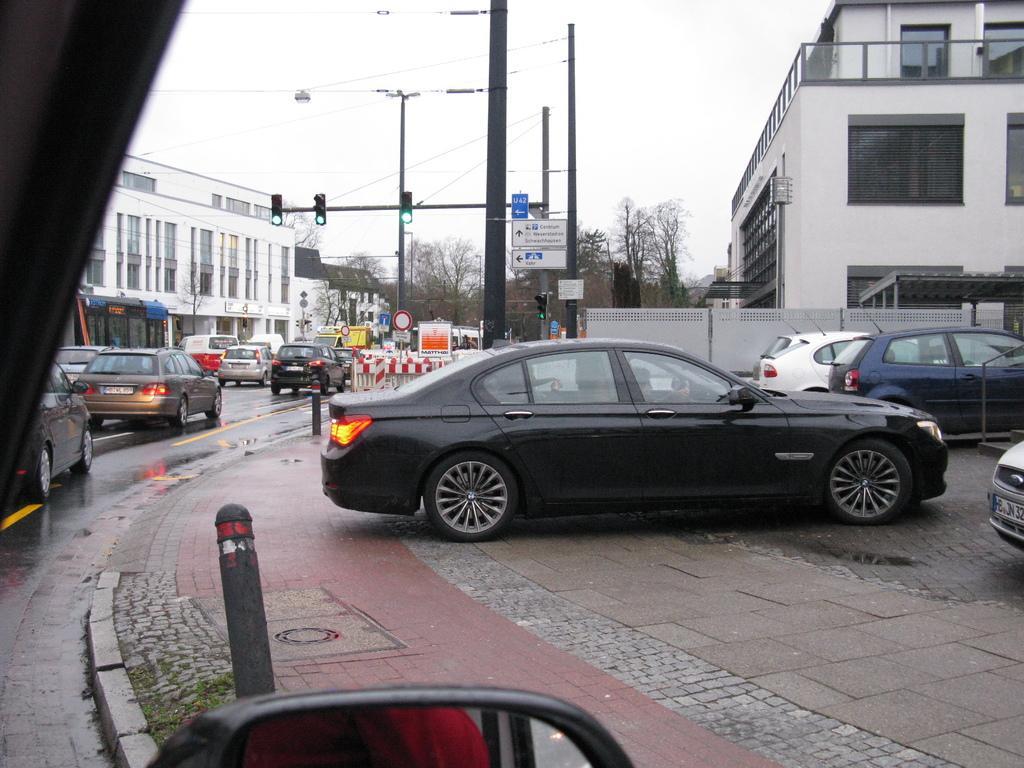In one or two sentences, can you explain what this image depicts? In this image we can see electric poles, electric cables, traffic poles, traffic signals, motor vehicles on the road, footpath, buildings, trees and sky. 